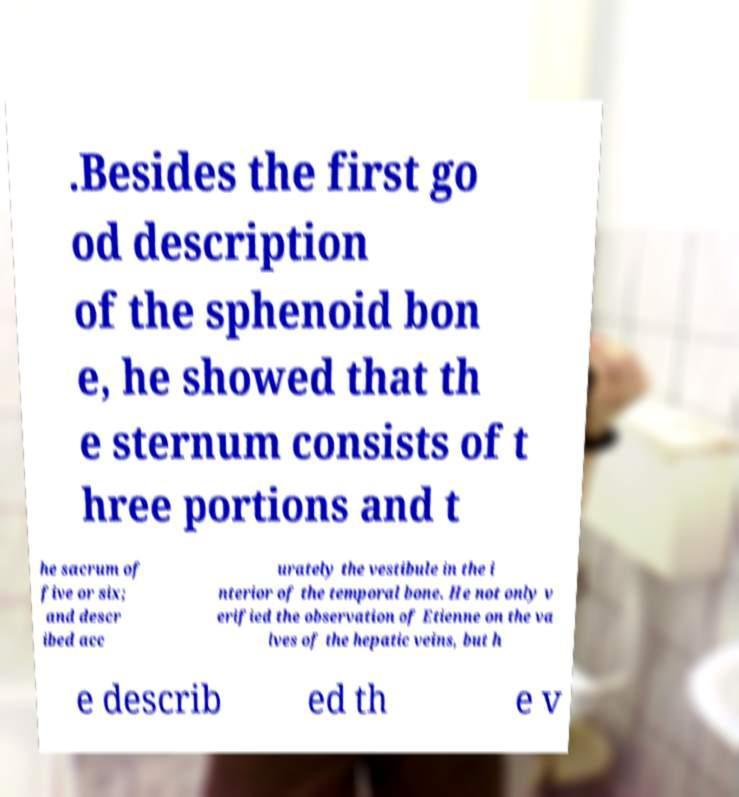Can you read and provide the text displayed in the image?This photo seems to have some interesting text. Can you extract and type it out for me? .Besides the first go od description of the sphenoid bon e, he showed that th e sternum consists of t hree portions and t he sacrum of five or six; and descr ibed acc urately the vestibule in the i nterior of the temporal bone. He not only v erified the observation of Etienne on the va lves of the hepatic veins, but h e describ ed th e v 